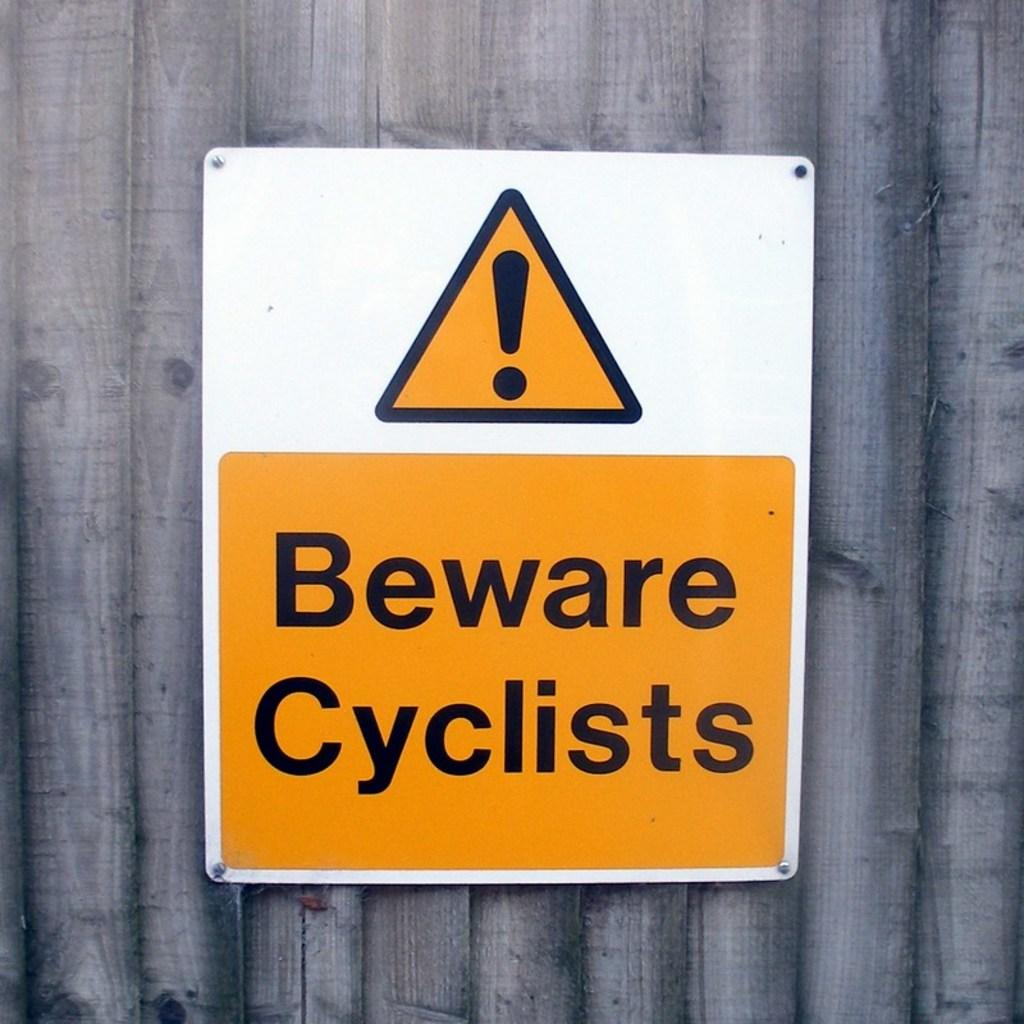<image>
Present a compact description of the photo's key features. An orange and white sign on a wooden fence says Beware Cyclists. 